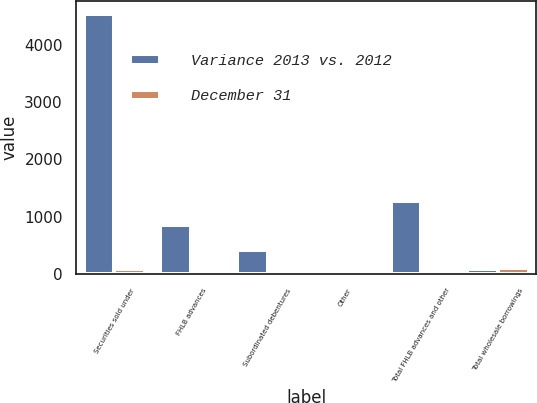Convert chart. <chart><loc_0><loc_0><loc_500><loc_500><stacked_bar_chart><ecel><fcel>Securities sold under<fcel>FHLB advances<fcel>Subordinated debentures<fcel>Other<fcel>Total FHLB advances and other<fcel>Total wholesale borrowings<nl><fcel>Variance 2013 vs. 2012<fcel>4542.8<fcel>850.9<fcel>427.8<fcel>0.4<fcel>1279.1<fcel>88.1<nl><fcel>December 31<fcel>88.1<fcel>19.2<fcel>0.1<fcel>1.1<fcel>18.2<fcel>106.3<nl></chart> 